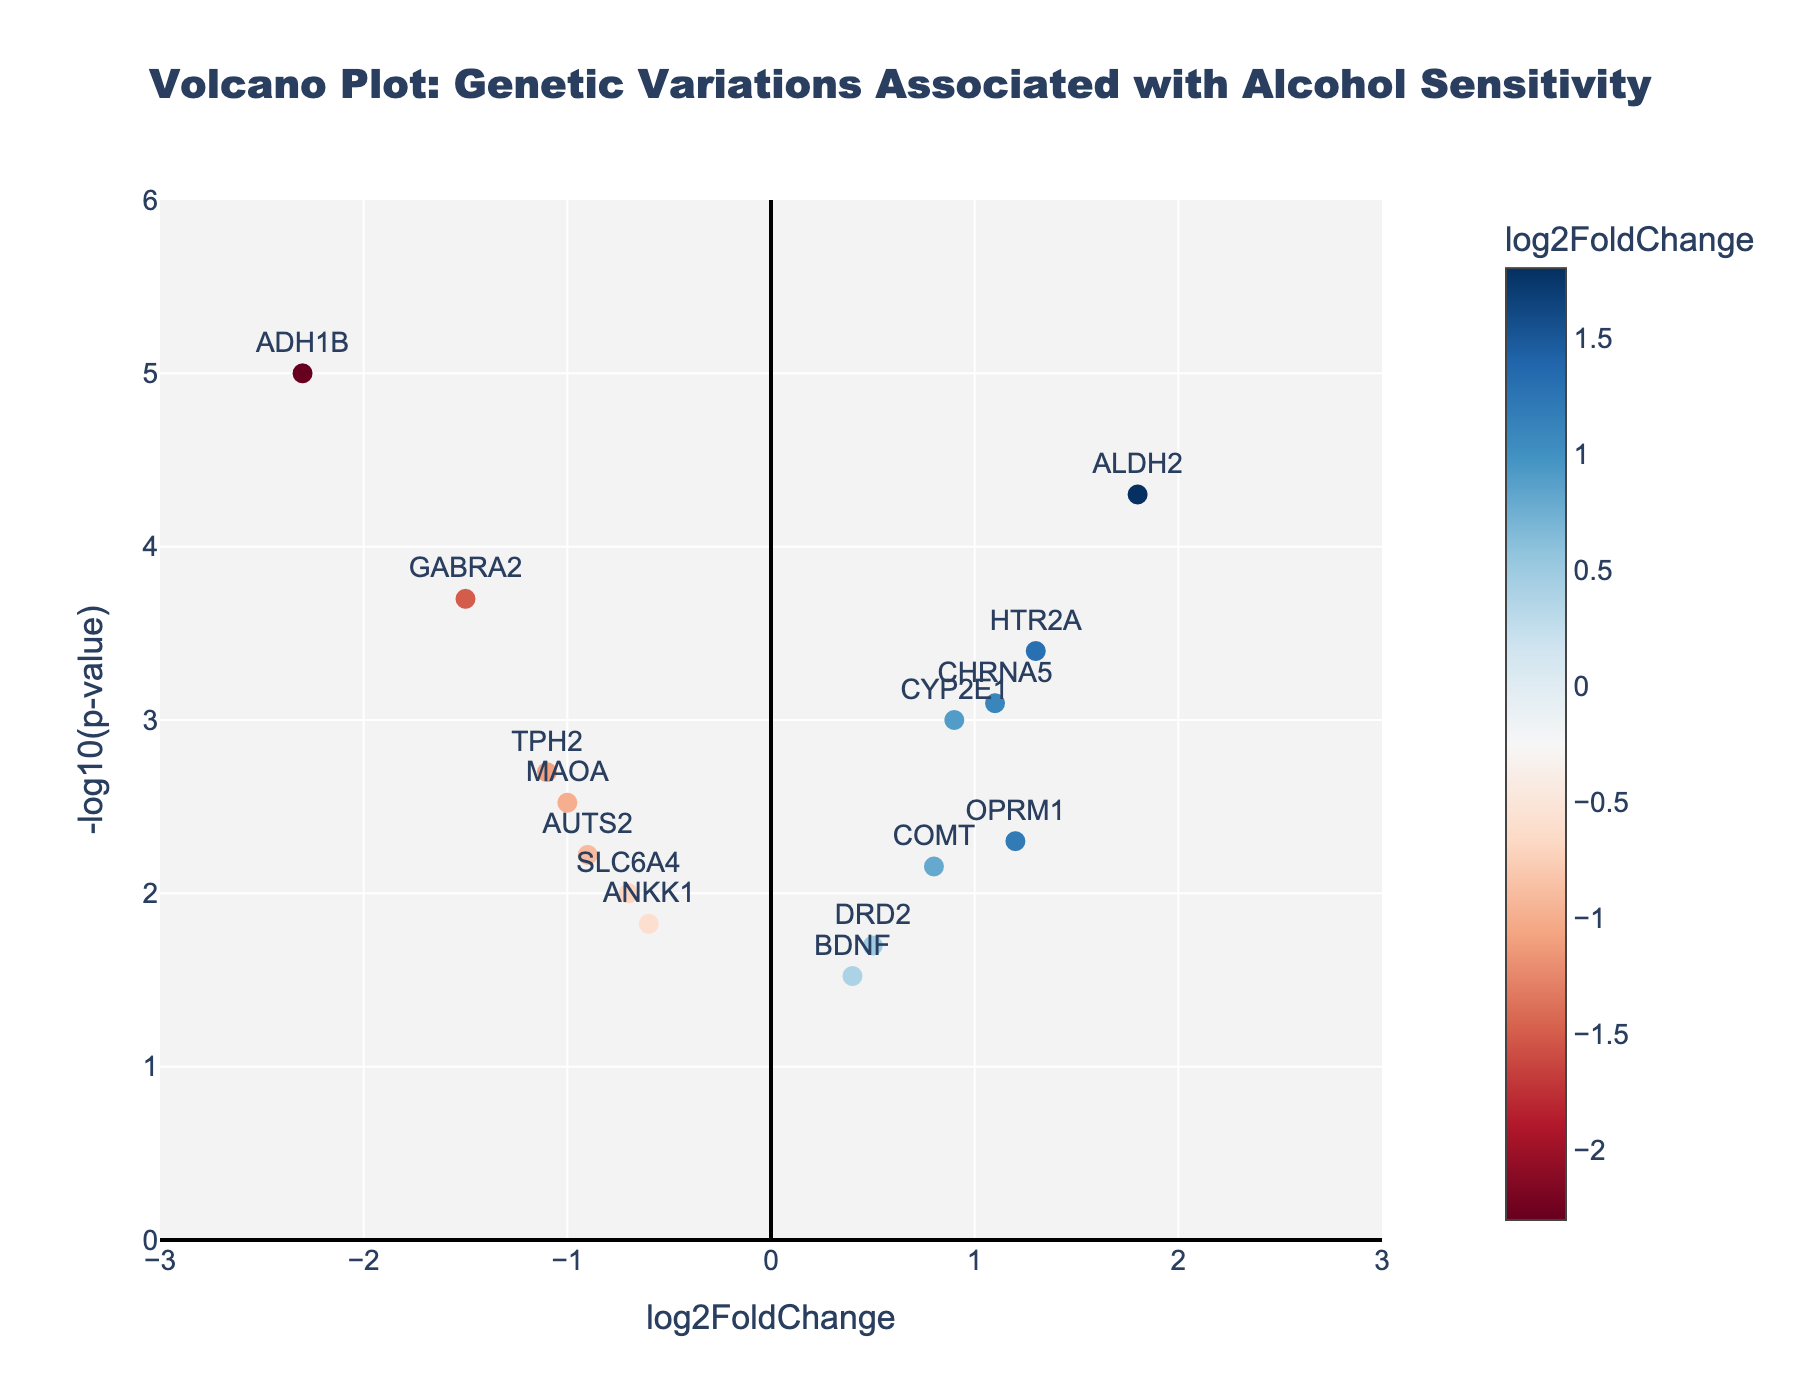What is the title of the figure? The title is found at the top of the figure and provides an overview of the plot's purpose, which is usually written in large, bold text to stand out.
Answer: Volcano Plot: Genetic Variations Associated with Alcohol Sensitivity What does the x-axis represent? The x-axis represents the log2FoldChange, which indicates the fold change in gene expression levels between different groups. This is found labeled along the horizontal axis of the plot.
Answer: log2FoldChange What does the y-axis represent? The y-axis represents -log10(p-value), which indicates the significance of the gene expression changes. This is found labeled along the vertical axis of the plot.
Answer: -log10(p-value) How many data points (genes) are plotted in the figure? Each data point represents a gene, and you can count the number of markers or points plotted in the figure to determine this.
Answer: 15 Which gene has the most significant p-value? The most significant p-value corresponds to the highest -log10(p-value) on the plot. By looking for the data point that is the highest on the y-axis, you can identify this gene.
Answer: ADH1B Which gene has the largest negative log2FoldChange? The largest negative log2FoldChange is indicated by the data point farthest to the left on the x-axis. By finding this point, you can identify the gene.
Answer: ADH1B Which gene shows the highest positive log2FoldChange? The highest positive log2FoldChange corresponds to the data point farthest to the right on the x-axis. By locating this point, you can identify the gene.
Answer: ALDH2 What is the log2FoldChange and p-value of the gene CHRNA5? You can find this gene on the plot and refer to its hover text, which displays the log2FoldChange and p-value as additional information. The hover text will show "CHRNA5<br>log2FC: 1.1<br>p-value: 0.0008"
Answer: log2FoldChange: 1.1, p-value: 0.0008 How do the significance levels (-log10(p-value)) of genes TPH2 and MAOA compare? To compare these two genes, find their positions on the y-axis. TPH2 is at -log10(p-value) of 2.70, and MAOA is at -log10(p-value) of 2.52, indicating that TPH2 is slightly more significant.
Answer: TPH2 is more significant than MAOA What is the average log2FoldChange of the genes ALDH2 and OPRM1? Calculate the average of the log2FoldChange values for ALDH2 (1.8) and OPRM1 (1.2). The average is (1.8 + 1.2) / 2 = 1.5
Answer: 1.5 